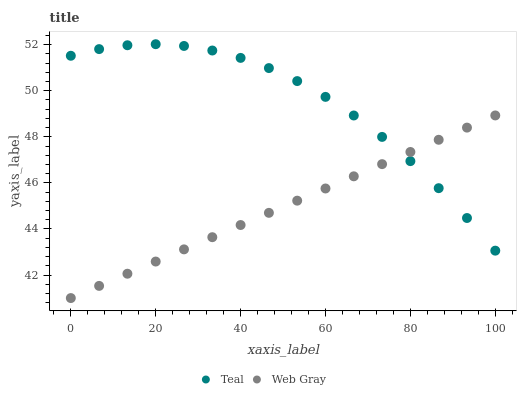Does Web Gray have the minimum area under the curve?
Answer yes or no. Yes. Does Teal have the maximum area under the curve?
Answer yes or no. Yes. Does Teal have the minimum area under the curve?
Answer yes or no. No. Is Web Gray the smoothest?
Answer yes or no. Yes. Is Teal the roughest?
Answer yes or no. Yes. Is Teal the smoothest?
Answer yes or no. No. Does Web Gray have the lowest value?
Answer yes or no. Yes. Does Teal have the lowest value?
Answer yes or no. No. Does Teal have the highest value?
Answer yes or no. Yes. Does Teal intersect Web Gray?
Answer yes or no. Yes. Is Teal less than Web Gray?
Answer yes or no. No. Is Teal greater than Web Gray?
Answer yes or no. No. 